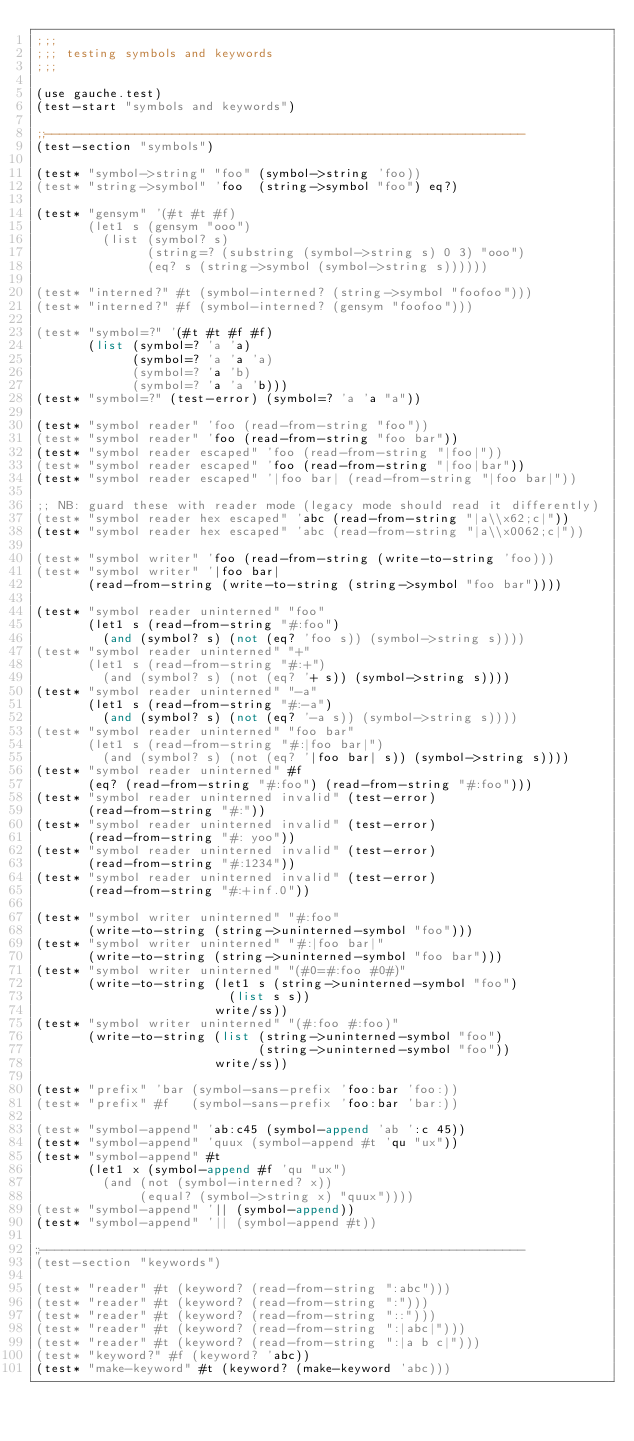Convert code to text. <code><loc_0><loc_0><loc_500><loc_500><_Scheme_>;;;
;;; testing symbols and keywords
;;;

(use gauche.test)
(test-start "symbols and keywords")

;;----------------------------------------------------------------
(test-section "symbols")

(test* "symbol->string" "foo" (symbol->string 'foo))
(test* "string->symbol" 'foo  (string->symbol "foo") eq?)

(test* "gensym" '(#t #t #f)
       (let1 s (gensym "ooo")
         (list (symbol? s)
               (string=? (substring (symbol->string s) 0 3) "ooo")
               (eq? s (string->symbol (symbol->string s))))))

(test* "interned?" #t (symbol-interned? (string->symbol "foofoo")))
(test* "interned?" #f (symbol-interned? (gensym "foofoo")))

(test* "symbol=?" '(#t #t #f #f)
       (list (symbol=? 'a 'a)
             (symbol=? 'a 'a 'a)
             (symbol=? 'a 'b)
             (symbol=? 'a 'a 'b)))
(test* "symbol=?" (test-error) (symbol=? 'a 'a "a"))

(test* "symbol reader" 'foo (read-from-string "foo"))
(test* "symbol reader" 'foo (read-from-string "foo bar"))
(test* "symbol reader escaped" 'foo (read-from-string "|foo|"))
(test* "symbol reader escaped" 'foo (read-from-string "|foo|bar"))
(test* "symbol reader escaped" '|foo bar| (read-from-string "|foo bar|"))

;; NB: guard these with reader mode (legacy mode should read it differently)
(test* "symbol reader hex escaped" 'abc (read-from-string "|a\\x62;c|"))
(test* "symbol reader hex escaped" 'abc (read-from-string "|a\\x0062;c|"))

(test* "symbol writer" 'foo (read-from-string (write-to-string 'foo)))
(test* "symbol writer" '|foo bar|
       (read-from-string (write-to-string (string->symbol "foo bar"))))

(test* "symbol reader uninterned" "foo"
       (let1 s (read-from-string "#:foo")
         (and (symbol? s) (not (eq? 'foo s)) (symbol->string s))))
(test* "symbol reader uninterned" "+"
       (let1 s (read-from-string "#:+")
         (and (symbol? s) (not (eq? '+ s)) (symbol->string s))))
(test* "symbol reader uninterned" "-a"
       (let1 s (read-from-string "#:-a")
         (and (symbol? s) (not (eq? '-a s)) (symbol->string s))))
(test* "symbol reader uninterned" "foo bar"
       (let1 s (read-from-string "#:|foo bar|")
         (and (symbol? s) (not (eq? '|foo bar| s)) (symbol->string s))))
(test* "symbol reader uninterned" #f
       (eq? (read-from-string "#:foo") (read-from-string "#:foo")))
(test* "symbol reader uninterned invalid" (test-error)
       (read-from-string "#:"))
(test* "symbol reader uninterned invalid" (test-error)
       (read-from-string "#: yoo"))
(test* "symbol reader uninterned invalid" (test-error)
       (read-from-string "#:1234"))
(test* "symbol reader uninterned invalid" (test-error)
       (read-from-string "#:+inf.0"))

(test* "symbol writer uninterned" "#:foo"
       (write-to-string (string->uninterned-symbol "foo")))
(test* "symbol writer uninterned" "#:|foo bar|"
       (write-to-string (string->uninterned-symbol "foo bar")))
(test* "symbol writer uninterned" "(#0=#:foo #0#)"
       (write-to-string (let1 s (string->uninterned-symbol "foo")
                          (list s s))
                        write/ss))
(test* "symbol writer uninterned" "(#:foo #:foo)"
       (write-to-string (list (string->uninterned-symbol "foo")
                              (string->uninterned-symbol "foo"))
                        write/ss))

(test* "prefix" 'bar (symbol-sans-prefix 'foo:bar 'foo:))
(test* "prefix" #f   (symbol-sans-prefix 'foo:bar 'bar:))

(test* "symbol-append" 'ab:c45 (symbol-append 'ab ':c 45))
(test* "symbol-append" 'quux (symbol-append #t 'qu "ux"))
(test* "symbol-append" #t
       (let1 x (symbol-append #f 'qu "ux")
         (and (not (symbol-interned? x))
              (equal? (symbol->string x) "quux"))))
(test* "symbol-append" '|| (symbol-append))
(test* "symbol-append" '|| (symbol-append #t))

;;----------------------------------------------------------------
(test-section "keywords")

(test* "reader" #t (keyword? (read-from-string ":abc")))
(test* "reader" #t (keyword? (read-from-string ":")))
(test* "reader" #t (keyword? (read-from-string "::")))
(test* "reader" #t (keyword? (read-from-string ":|abc|")))
(test* "reader" #t (keyword? (read-from-string ":|a b c|")))
(test* "keyword?" #f (keyword? 'abc))
(test* "make-keyword" #t (keyword? (make-keyword 'abc)))</code> 